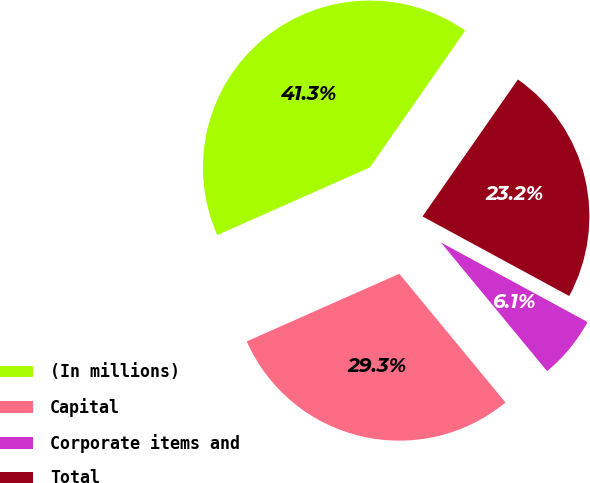Convert chart to OTSL. <chart><loc_0><loc_0><loc_500><loc_500><pie_chart><fcel>(In millions)<fcel>Capital<fcel>Corporate items and<fcel>Total<nl><fcel>41.33%<fcel>29.34%<fcel>6.11%<fcel>23.23%<nl></chart> 